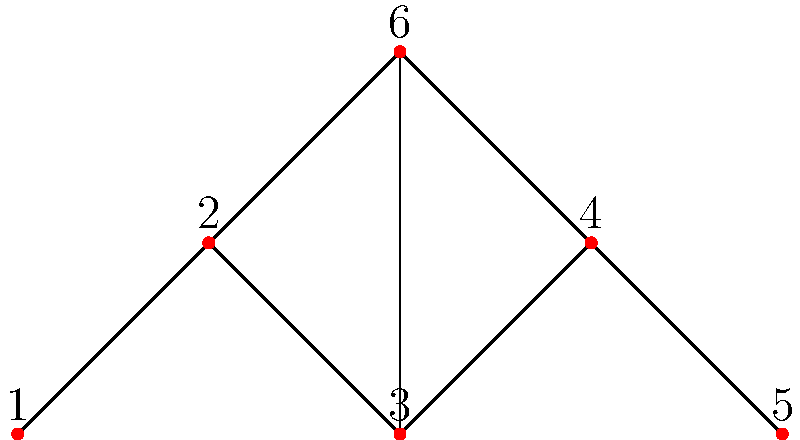In the given connected graph, identify all bridges and articulation points. How many bridges and articulation points are there in total? To identify bridges and articulation points, we need to analyze the graph structure:

1. Bridges:
   - Edge (1,2): Removing this edge disconnects vertex 1 from the rest of the graph.
   - Edge (4,5): Removing this edge disconnects vertex 5 from the rest of the graph.

2. Articulation points:
   - Vertex 2: Removing this vertex disconnects vertex 1 from the rest of the graph.
   - Vertex 4: Removing this vertex disconnects vertex 5 from the rest of the graph.
   - Vertex 3: Removing this vertex splits the graph into three components (1-2, 5-6, 4).

To verify these:
- Try removing each edge and check if the graph becomes disconnected.
- Try removing each vertex and its incident edges, then check if the remaining graph becomes disconnected or if the number of connected components increases.

Count:
- Bridges: 2
- Articulation points: 3

Total: 2 + 3 = 5
Answer: 5 